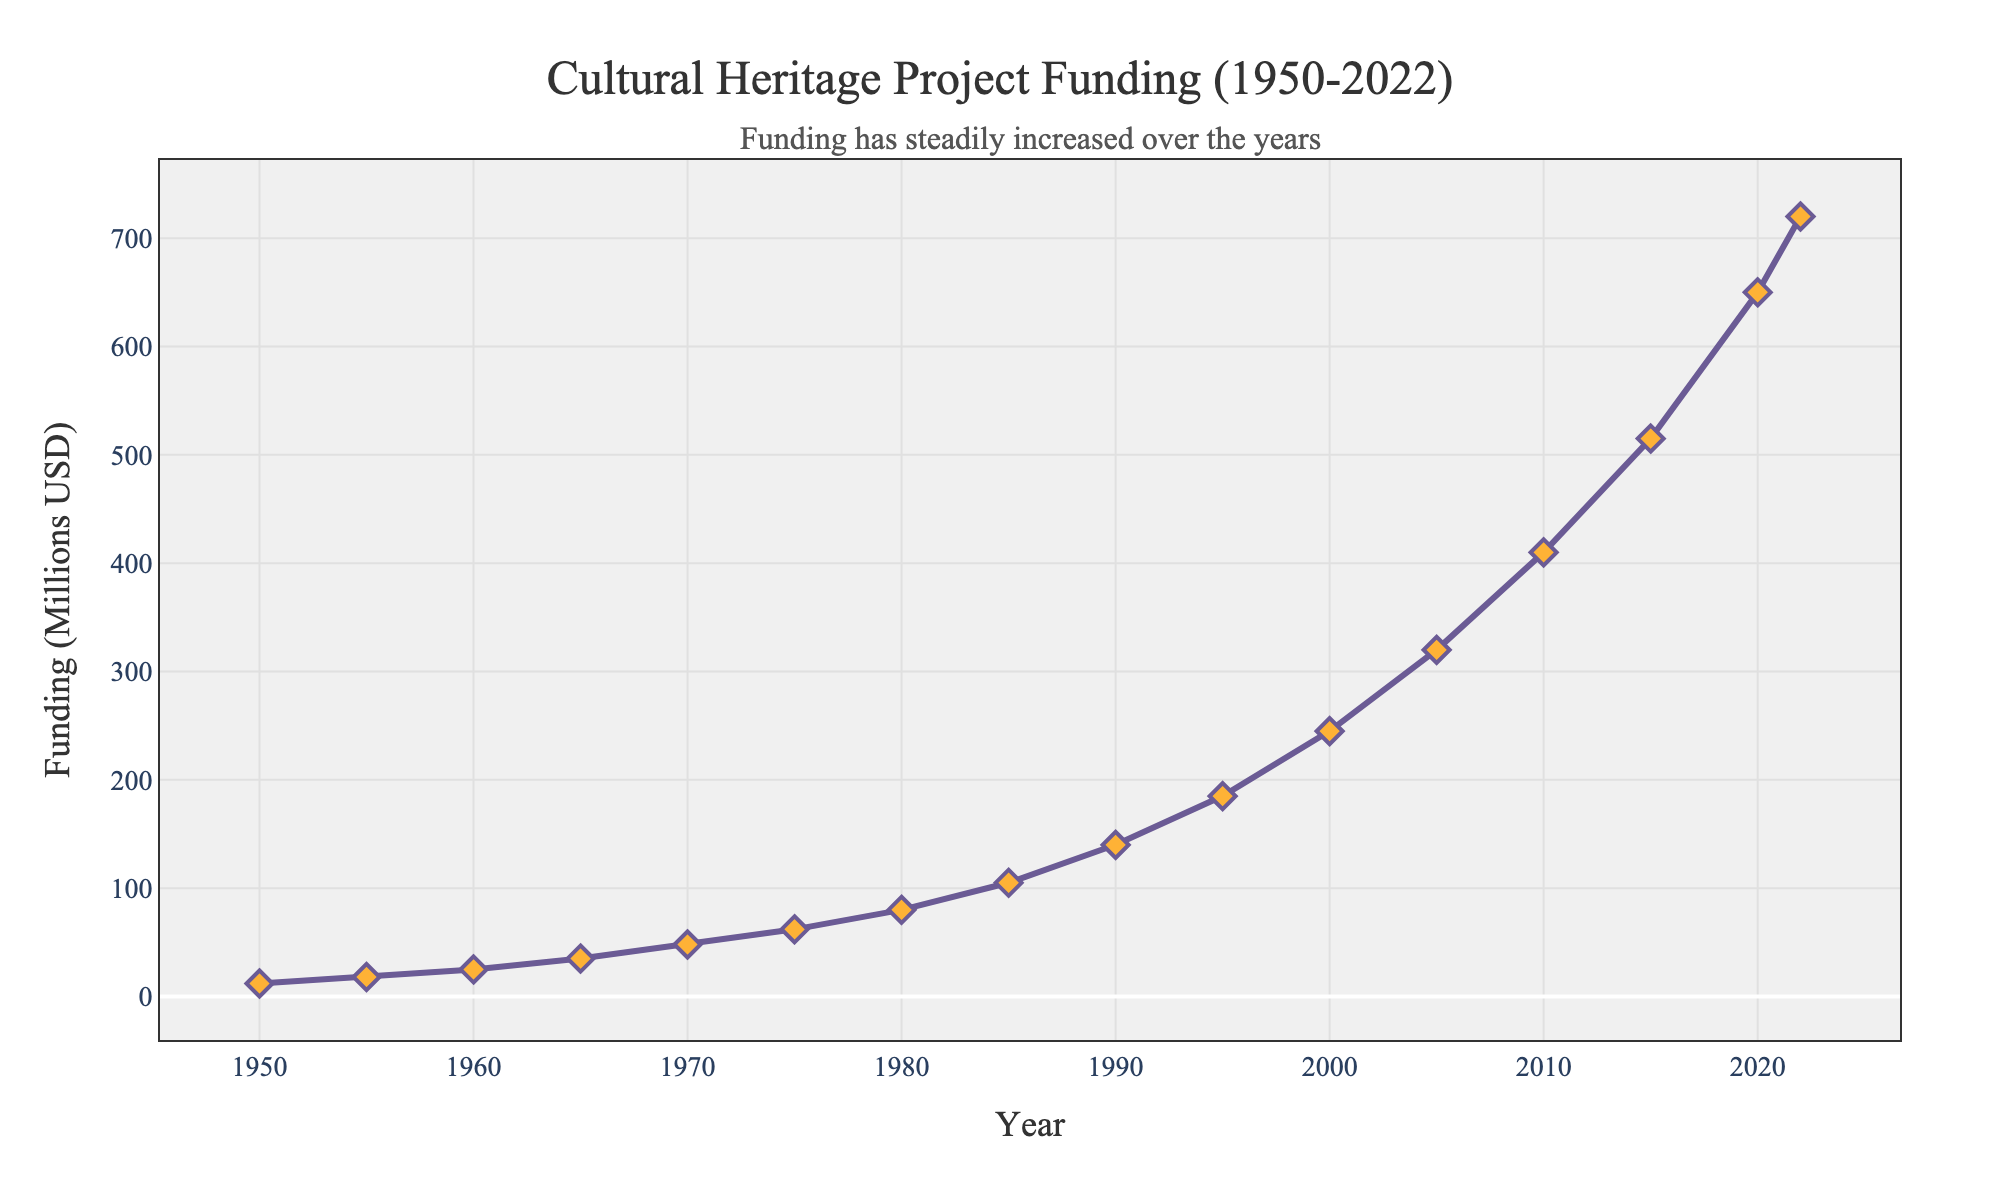How much did the funding increase from 1950 to 2022? To determine the increase, subtract the funding value in 1950 from the funding value in 2022. That is, 720 million USD (2022) - 12 million USD (1950) = 708 million USD.
Answer: 708 million USD What is the average annual funding between 1950 and 2022? First, count the number of years between 1950 and 2022, which is (2022 - 1950 + 1) = 73 years. Then, sum all the funding values and divide by the number of years. The sum of the given data points is 3500 million USD. Therefore, the average annual funding is 3500 / 73 ≈ 47.95 million USD.
Answer: 47.95 million USD Which year had the highest funding and how much was it? The highest funding can be identified by locating the highest point on the chart. From the data, the highest funding is in 2022 with a value of 720 million USD.
Answer: 2022, 720 million USD What was the funding trend between 1950 and 1970? Look at the chart segment from 1950 to 1970 to see how the funding values change. The funding increased from 12 million USD in 1950 to 48 million USD in 1970.
Answer: Increasing Is the funding in 2000 greater than the funding in 1990? Compare the values from the data or chart for the years 2000 and 1990. In 2000, the funding was 245 million USD, while in 1990 it was 140 million USD. Hence, 245 > 140.
Answer: Yes How does the funding in 1980 compare to the funding in 1985? Compare the funding values for the years 1980 and 1985 directly from the chart. The funding in 1980 was 80 million USD, whereas in 1985 it was 105 million USD. Therefore, 105 > 80.
Answer: Funding in 1985 is greater What is the difference in funding between 1975 and 1980? Subtract the funding value in 1975 from the value in 1980. That is, 80 million USD (1980) - 62 million USD (1975) = 18 million USD.
Answer: 18 million USD How many times did the funding exceed 200 million USD between 1950 and 2022? Identify the years when the funding was more than 200 million USD. From the chart, the years are 2000, 2005, 2010, 2015, 2020, and 2022, which totals to 6 times.
Answer: 6 times What can be observed about the overall trend in funding from 1950 to 2022? Observing the entire chart from 1950 to 2022 shows a general upward trend, indicating a consistent increase in funding over the years.
Answer: Steadily increasing What's the average funding for the decades 1990s and 2000s? Average each set of yearly funding values within the decades and then find the average of these averages. For the 1990s decade: (140 + 185) / 2 = 162.5 million USD. For the 2000s decade: (245 + 320) / 2 = 282.5 million USD. The overall average is (162.5 + 282.5) / 2 = 222.5 million USD.
Answer: 222.5 million USD 